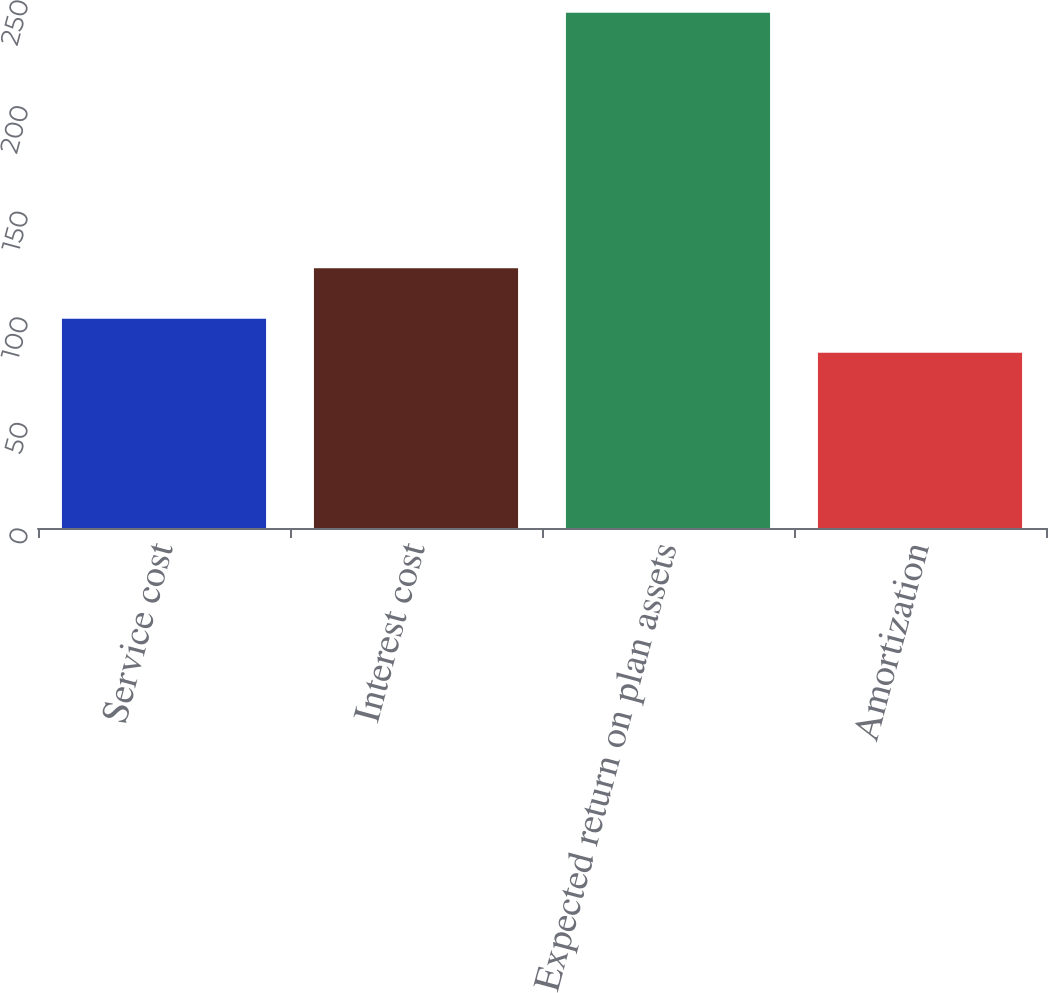<chart> <loc_0><loc_0><loc_500><loc_500><bar_chart><fcel>Service cost<fcel>Interest cost<fcel>Expected return on plan assets<fcel>Amortization<nl><fcel>99.1<fcel>123<fcel>244<fcel>83<nl></chart> 